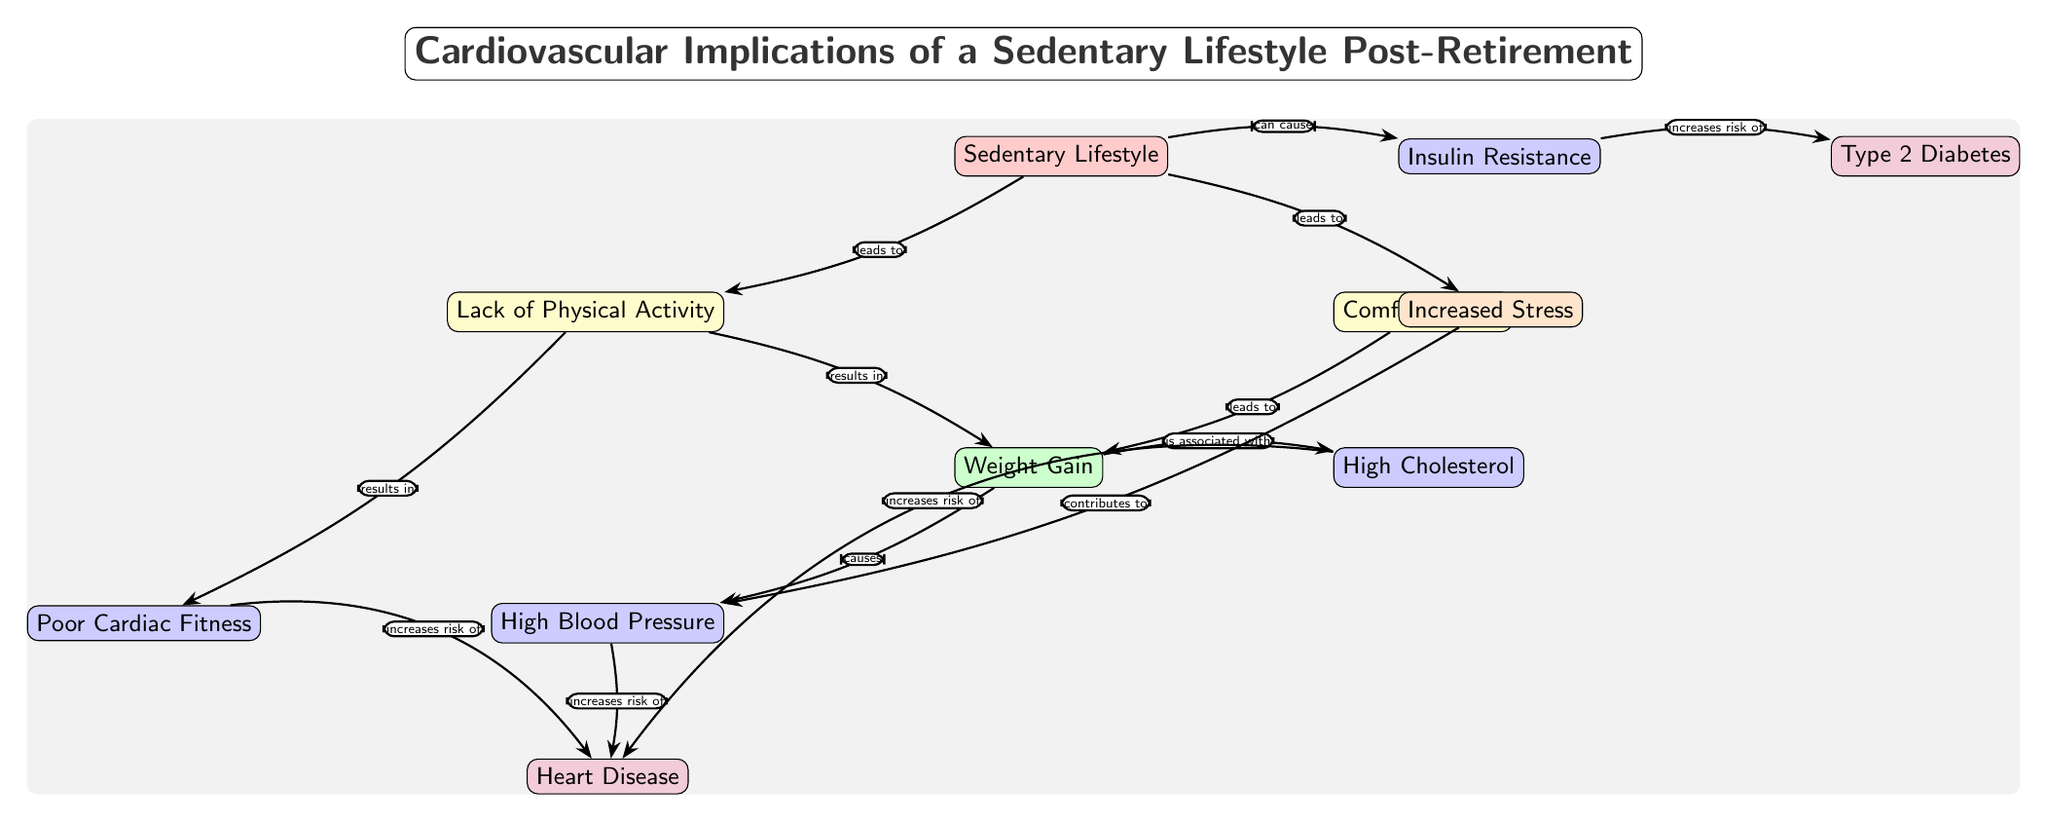What is the central risk factor in the diagram? The central risk factor node is labeled "Sedentary Lifestyle," which is the starting point of the diagram.
Answer: Sedentary Lifestyle How many conditions are linked to the weight gain node? There are two conditions associated with the "Weight Gain" node in the diagram: "High Blood Pressure" and "High Cholesterol."
Answer: 2 What disease is directly linked to high blood pressure? The diagram shows that "High Blood Pressure" increases the risk of "Heart Disease."
Answer: Heart Disease What behavior contributes to weight gain aside from lack of physical activity? The diagram indicates that "Comfort Eating" also leads to "Weight Gain."
Answer: Comfort Eating What effect does a sedentary lifestyle have on stress levels? According to the diagram, a sedentary lifestyle leads to "Increased Stress," indicating a direct relationship.
Answer: Increased Stress How does insulin resistance affect the risk of diabetes? The diagram illustrates that "Insulin Resistance" increases the risk of "Type 2 Diabetes," showing a clear connection.
Answer: Increases risk of Type 2 Diabetes Which condition is a consequence of a lack of physical activity? The lack of physical activity results in "Poor Cardiac Fitness," as shown in the diagram.
Answer: Poor Cardiac Fitness How does increased stress impact heart disease? The diagram explains that increased stress contributes to "High Blood Pressure," which further increases the risk of "Heart Disease."
Answer: Increases risk of Heart Disease 